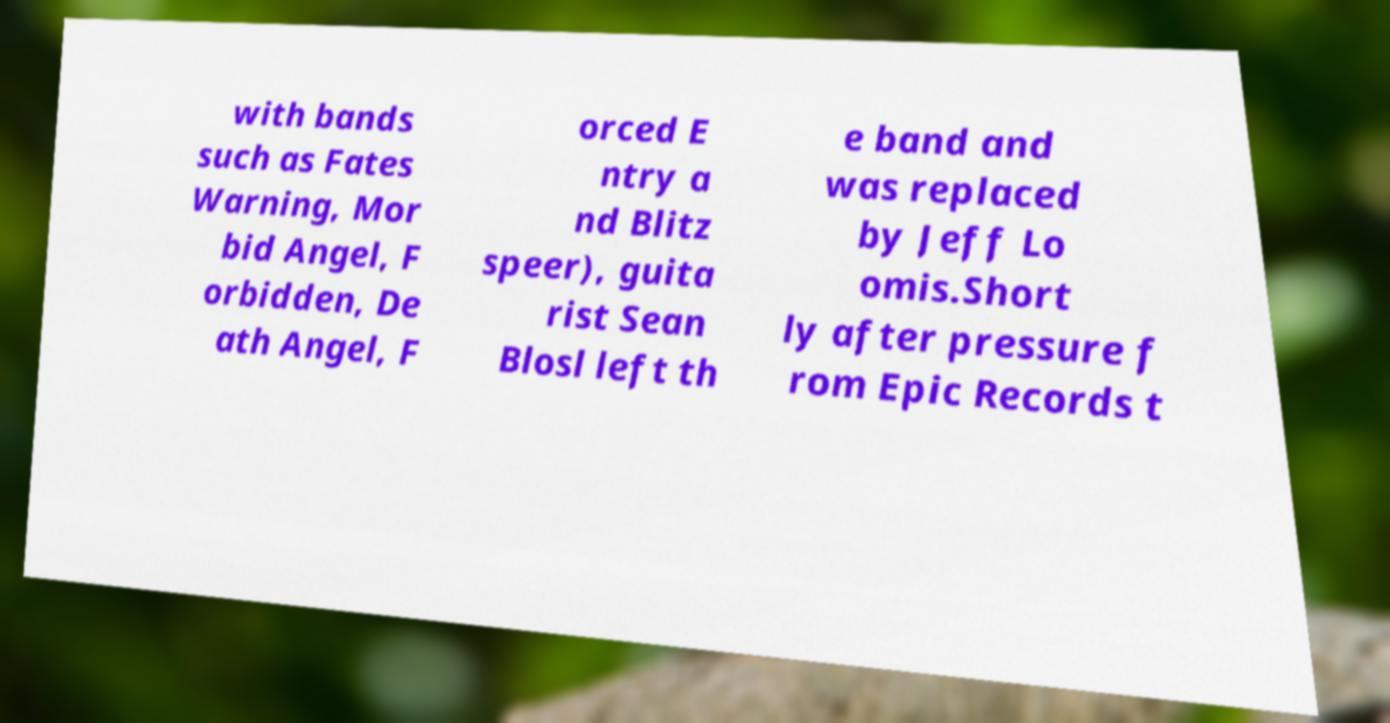Please identify and transcribe the text found in this image. with bands such as Fates Warning, Mor bid Angel, F orbidden, De ath Angel, F orced E ntry a nd Blitz speer), guita rist Sean Blosl left th e band and was replaced by Jeff Lo omis.Short ly after pressure f rom Epic Records t 